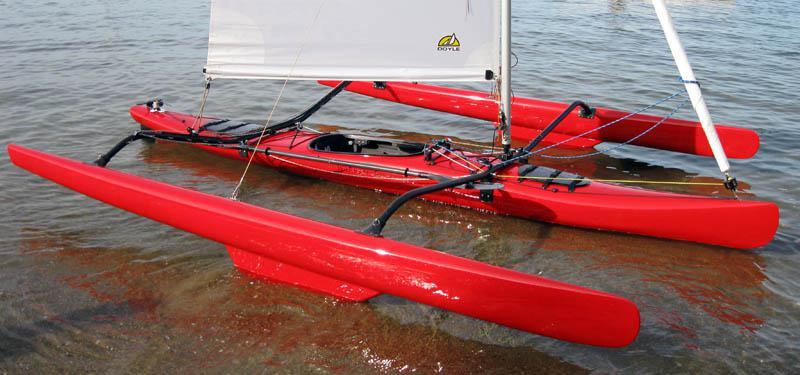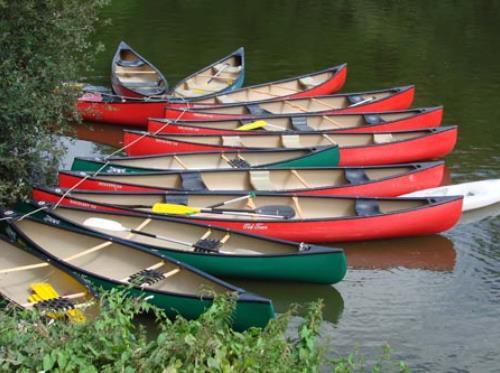The first image is the image on the left, the second image is the image on the right. Assess this claim about the two images: "An image shows a curving row of at least ten canoes, none containing humans.". Correct or not? Answer yes or no. Yes. 